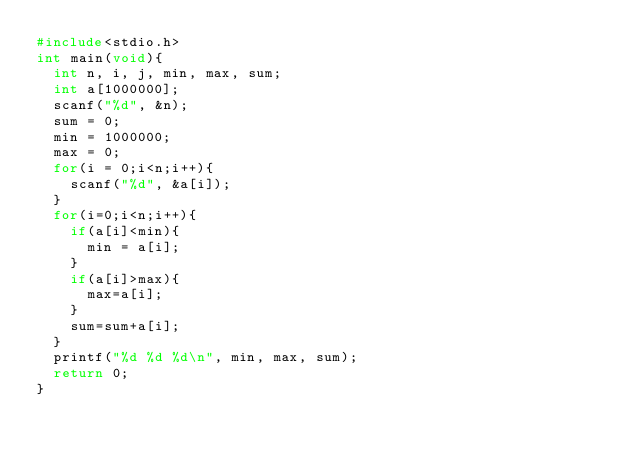Convert code to text. <code><loc_0><loc_0><loc_500><loc_500><_C_>#include<stdio.h>
int main(void){
  int n, i, j, min, max, sum;
  int a[1000000];
  scanf("%d", &n);
  sum = 0;
  min = 1000000;
  max = 0;
  for(i = 0;i<n;i++){
    scanf("%d", &a[i]);
  }
  for(i=0;i<n;i++){
    if(a[i]<min){
      min = a[i];
    }
    if(a[i]>max){
      max=a[i];
    }
    sum=sum+a[i];
  }
  printf("%d %d %d\n", min, max, sum);
  return 0;
}
</code> 